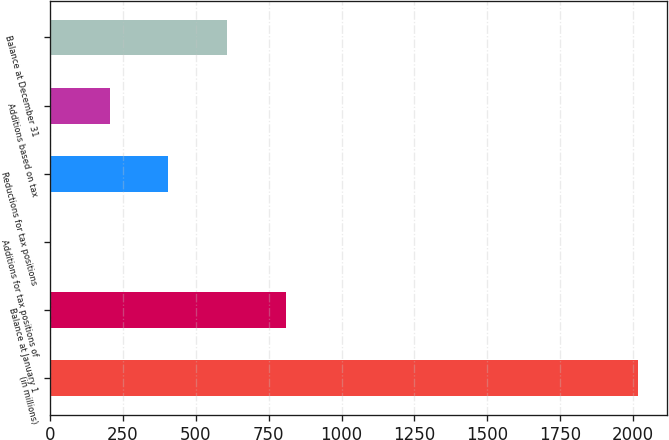Convert chart. <chart><loc_0><loc_0><loc_500><loc_500><bar_chart><fcel>(in millions)<fcel>Balance at January 1<fcel>Additions for tax positions of<fcel>Reductions for tax positions<fcel>Additions based on tax<fcel>Balance at December 31<nl><fcel>2016<fcel>808.2<fcel>3<fcel>405.6<fcel>204.3<fcel>606.9<nl></chart> 